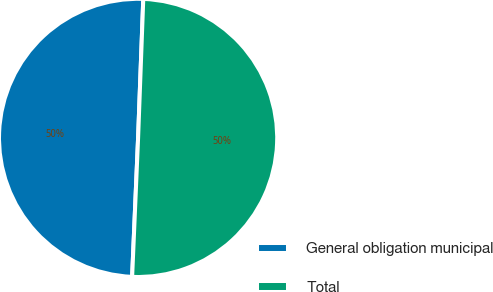Convert chart to OTSL. <chart><loc_0><loc_0><loc_500><loc_500><pie_chart><fcel>General obligation municipal<fcel>Total<nl><fcel>49.91%<fcel>50.09%<nl></chart> 